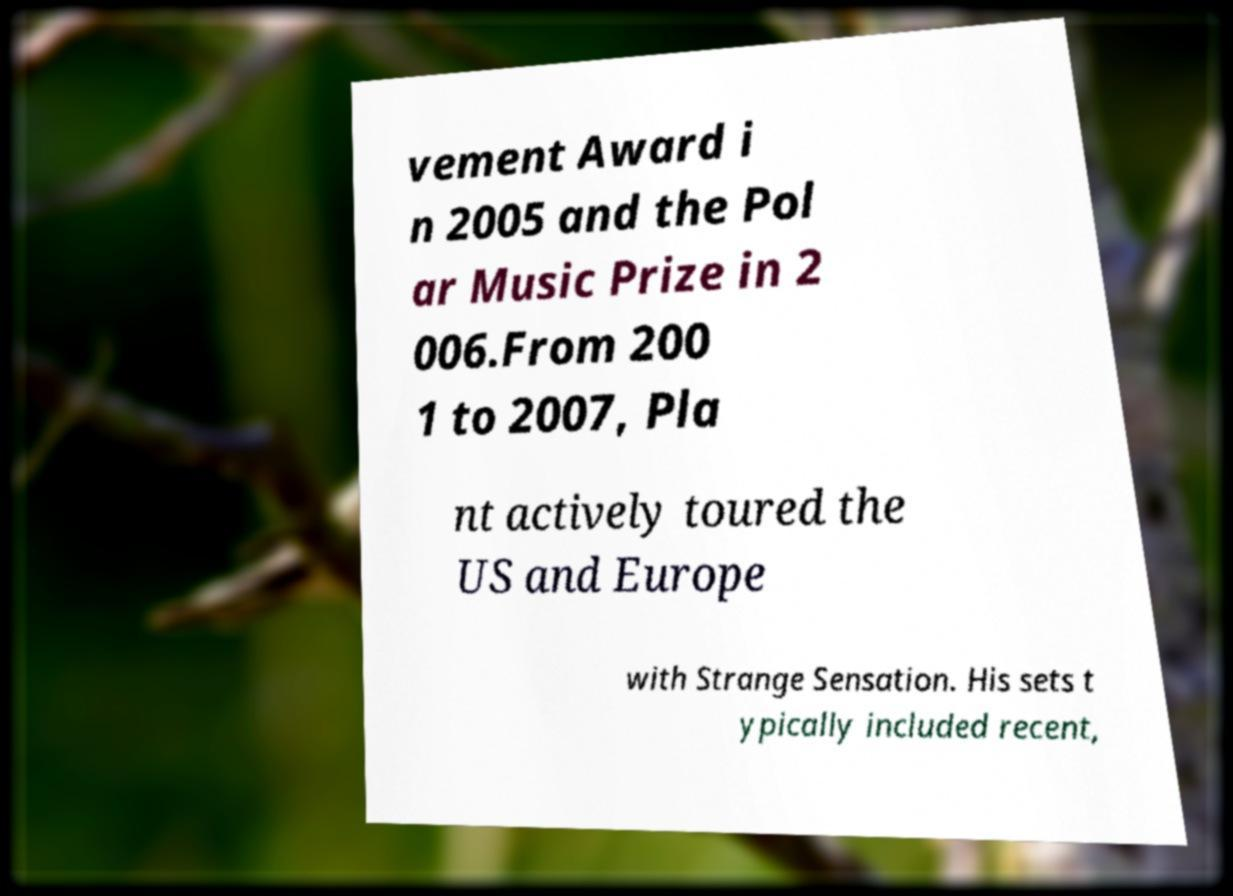What messages or text are displayed in this image? I need them in a readable, typed format. vement Award i n 2005 and the Pol ar Music Prize in 2 006.From 200 1 to 2007, Pla nt actively toured the US and Europe with Strange Sensation. His sets t ypically included recent, 